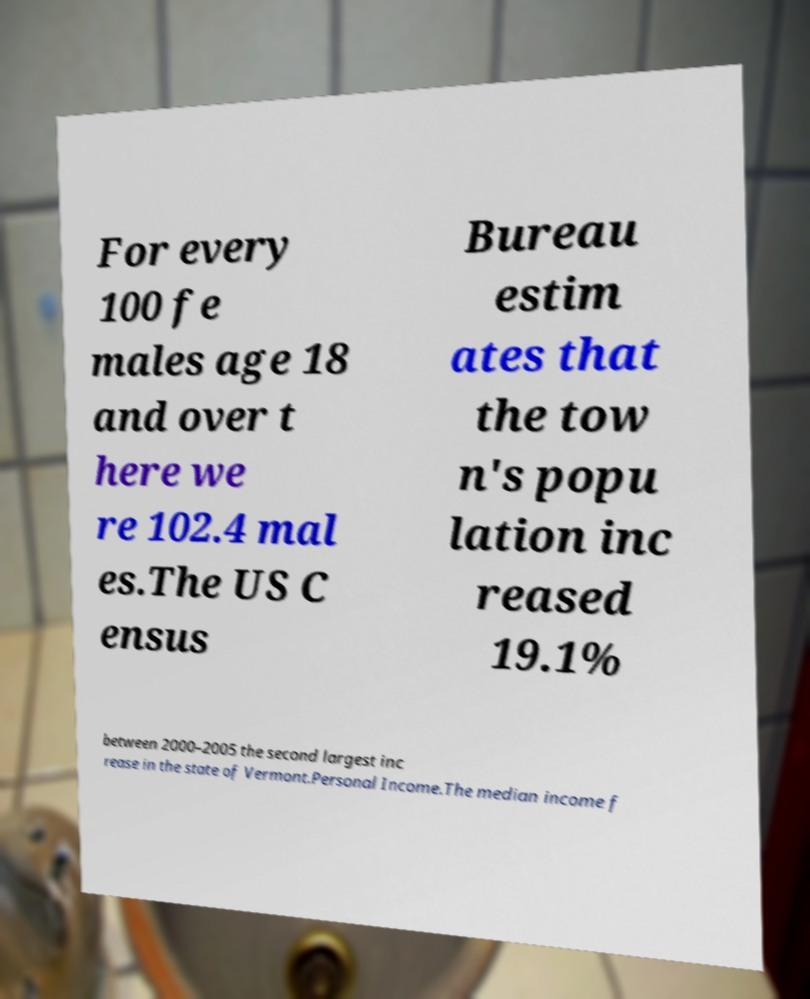Please read and relay the text visible in this image. What does it say? For every 100 fe males age 18 and over t here we re 102.4 mal es.The US C ensus Bureau estim ates that the tow n's popu lation inc reased 19.1% between 2000–2005 the second largest inc rease in the state of Vermont.Personal Income.The median income f 